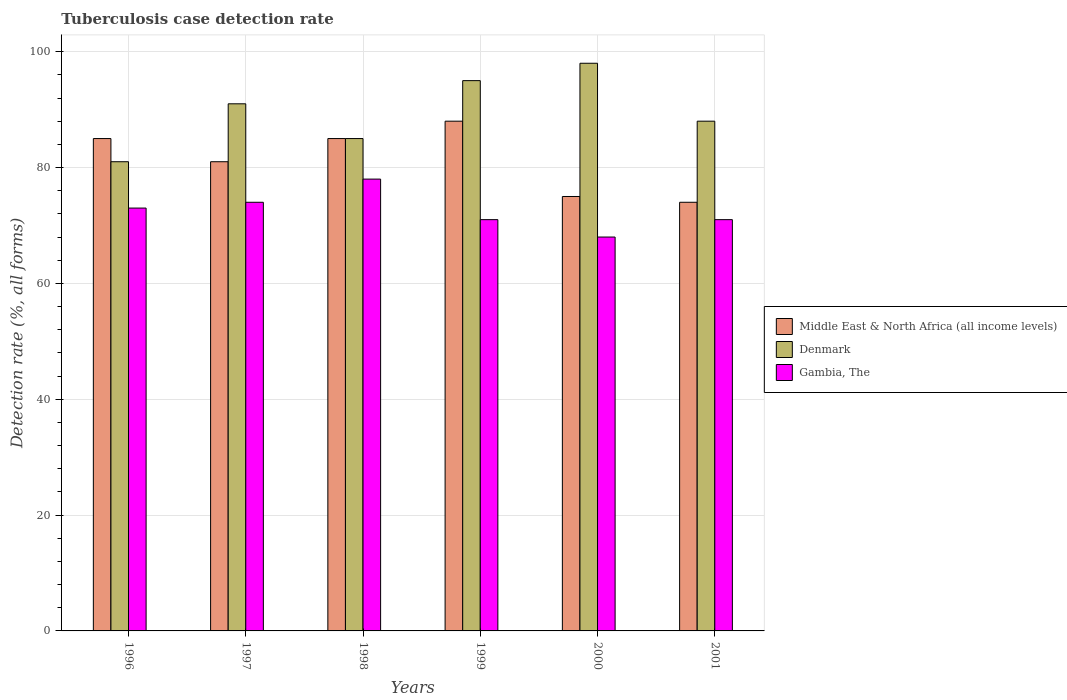In how many cases, is the number of bars for a given year not equal to the number of legend labels?
Provide a short and direct response. 0. Across all years, what is the maximum tuberculosis case detection rate in in Middle East & North Africa (all income levels)?
Give a very brief answer. 88. Across all years, what is the minimum tuberculosis case detection rate in in Gambia, The?
Your answer should be very brief. 68. In which year was the tuberculosis case detection rate in in Gambia, The maximum?
Ensure brevity in your answer.  1998. In which year was the tuberculosis case detection rate in in Middle East & North Africa (all income levels) minimum?
Your answer should be very brief. 2001. What is the total tuberculosis case detection rate in in Middle East & North Africa (all income levels) in the graph?
Provide a succinct answer. 488. What is the difference between the tuberculosis case detection rate in in Middle East & North Africa (all income levels) in 2000 and that in 2001?
Your answer should be very brief. 1. What is the difference between the tuberculosis case detection rate in in Middle East & North Africa (all income levels) in 1998 and the tuberculosis case detection rate in in Gambia, The in 2001?
Provide a succinct answer. 14. What is the average tuberculosis case detection rate in in Gambia, The per year?
Keep it short and to the point. 72.5. In the year 2001, what is the difference between the tuberculosis case detection rate in in Middle East & North Africa (all income levels) and tuberculosis case detection rate in in Gambia, The?
Offer a terse response. 3. What is the ratio of the tuberculosis case detection rate in in Denmark in 1997 to that in 1999?
Give a very brief answer. 0.96. What is the difference between the highest and the lowest tuberculosis case detection rate in in Denmark?
Your answer should be very brief. 17. In how many years, is the tuberculosis case detection rate in in Denmark greater than the average tuberculosis case detection rate in in Denmark taken over all years?
Your answer should be compact. 3. Is the sum of the tuberculosis case detection rate in in Middle East & North Africa (all income levels) in 1998 and 1999 greater than the maximum tuberculosis case detection rate in in Denmark across all years?
Your response must be concise. Yes. What does the 1st bar from the left in 1999 represents?
Provide a succinct answer. Middle East & North Africa (all income levels). What does the 2nd bar from the right in 2001 represents?
Offer a very short reply. Denmark. Is it the case that in every year, the sum of the tuberculosis case detection rate in in Gambia, The and tuberculosis case detection rate in in Middle East & North Africa (all income levels) is greater than the tuberculosis case detection rate in in Denmark?
Make the answer very short. Yes. Are all the bars in the graph horizontal?
Keep it short and to the point. No. How many years are there in the graph?
Your answer should be very brief. 6. Does the graph contain any zero values?
Give a very brief answer. No. Does the graph contain grids?
Keep it short and to the point. Yes. How are the legend labels stacked?
Provide a succinct answer. Vertical. What is the title of the graph?
Ensure brevity in your answer.  Tuberculosis case detection rate. What is the label or title of the X-axis?
Give a very brief answer. Years. What is the label or title of the Y-axis?
Ensure brevity in your answer.  Detection rate (%, all forms). What is the Detection rate (%, all forms) of Middle East & North Africa (all income levels) in 1996?
Keep it short and to the point. 85. What is the Detection rate (%, all forms) in Middle East & North Africa (all income levels) in 1997?
Your response must be concise. 81. What is the Detection rate (%, all forms) in Denmark in 1997?
Make the answer very short. 91. What is the Detection rate (%, all forms) in Middle East & North Africa (all income levels) in 1998?
Keep it short and to the point. 85. What is the Detection rate (%, all forms) in Gambia, The in 1998?
Your answer should be compact. 78. What is the Detection rate (%, all forms) in Denmark in 1999?
Offer a very short reply. 95. What is the Detection rate (%, all forms) in Middle East & North Africa (all income levels) in 2000?
Provide a succinct answer. 75. Across all years, what is the maximum Detection rate (%, all forms) in Middle East & North Africa (all income levels)?
Make the answer very short. 88. Across all years, what is the maximum Detection rate (%, all forms) of Denmark?
Give a very brief answer. 98. Across all years, what is the minimum Detection rate (%, all forms) in Middle East & North Africa (all income levels)?
Offer a terse response. 74. Across all years, what is the minimum Detection rate (%, all forms) in Gambia, The?
Offer a terse response. 68. What is the total Detection rate (%, all forms) of Middle East & North Africa (all income levels) in the graph?
Offer a terse response. 488. What is the total Detection rate (%, all forms) of Denmark in the graph?
Keep it short and to the point. 538. What is the total Detection rate (%, all forms) in Gambia, The in the graph?
Make the answer very short. 435. What is the difference between the Detection rate (%, all forms) in Denmark in 1996 and that in 1997?
Offer a terse response. -10. What is the difference between the Detection rate (%, all forms) of Gambia, The in 1996 and that in 1997?
Ensure brevity in your answer.  -1. What is the difference between the Detection rate (%, all forms) of Middle East & North Africa (all income levels) in 1996 and that in 1998?
Make the answer very short. 0. What is the difference between the Detection rate (%, all forms) in Middle East & North Africa (all income levels) in 1996 and that in 1999?
Keep it short and to the point. -3. What is the difference between the Detection rate (%, all forms) in Gambia, The in 1996 and that in 1999?
Make the answer very short. 2. What is the difference between the Detection rate (%, all forms) in Gambia, The in 1996 and that in 2000?
Give a very brief answer. 5. What is the difference between the Detection rate (%, all forms) of Denmark in 1996 and that in 2001?
Your answer should be compact. -7. What is the difference between the Detection rate (%, all forms) of Gambia, The in 1996 and that in 2001?
Make the answer very short. 2. What is the difference between the Detection rate (%, all forms) in Denmark in 1997 and that in 1998?
Give a very brief answer. 6. What is the difference between the Detection rate (%, all forms) of Gambia, The in 1997 and that in 1998?
Your response must be concise. -4. What is the difference between the Detection rate (%, all forms) in Middle East & North Africa (all income levels) in 1997 and that in 1999?
Offer a very short reply. -7. What is the difference between the Detection rate (%, all forms) in Gambia, The in 1997 and that in 1999?
Give a very brief answer. 3. What is the difference between the Detection rate (%, all forms) of Middle East & North Africa (all income levels) in 1997 and that in 2000?
Offer a terse response. 6. What is the difference between the Detection rate (%, all forms) of Middle East & North Africa (all income levels) in 1998 and that in 2000?
Provide a short and direct response. 10. What is the difference between the Detection rate (%, all forms) of Denmark in 1998 and that in 2000?
Offer a terse response. -13. What is the difference between the Detection rate (%, all forms) in Middle East & North Africa (all income levels) in 1998 and that in 2001?
Your answer should be compact. 11. What is the difference between the Detection rate (%, all forms) of Middle East & North Africa (all income levels) in 1999 and that in 2000?
Provide a succinct answer. 13. What is the difference between the Detection rate (%, all forms) in Denmark in 1999 and that in 2001?
Keep it short and to the point. 7. What is the difference between the Detection rate (%, all forms) in Gambia, The in 1999 and that in 2001?
Provide a succinct answer. 0. What is the difference between the Detection rate (%, all forms) of Middle East & North Africa (all income levels) in 2000 and that in 2001?
Offer a terse response. 1. What is the difference between the Detection rate (%, all forms) of Denmark in 2000 and that in 2001?
Your response must be concise. 10. What is the difference between the Detection rate (%, all forms) in Middle East & North Africa (all income levels) in 1996 and the Detection rate (%, all forms) in Gambia, The in 1997?
Give a very brief answer. 11. What is the difference between the Detection rate (%, all forms) in Denmark in 1996 and the Detection rate (%, all forms) in Gambia, The in 1997?
Your answer should be compact. 7. What is the difference between the Detection rate (%, all forms) of Denmark in 1996 and the Detection rate (%, all forms) of Gambia, The in 1998?
Provide a short and direct response. 3. What is the difference between the Detection rate (%, all forms) of Middle East & North Africa (all income levels) in 1996 and the Detection rate (%, all forms) of Denmark in 1999?
Offer a very short reply. -10. What is the difference between the Detection rate (%, all forms) in Middle East & North Africa (all income levels) in 1996 and the Detection rate (%, all forms) in Gambia, The in 1999?
Give a very brief answer. 14. What is the difference between the Detection rate (%, all forms) of Denmark in 1996 and the Detection rate (%, all forms) of Gambia, The in 2001?
Your response must be concise. 10. What is the difference between the Detection rate (%, all forms) in Middle East & North Africa (all income levels) in 1997 and the Detection rate (%, all forms) in Denmark in 1998?
Offer a terse response. -4. What is the difference between the Detection rate (%, all forms) in Middle East & North Africa (all income levels) in 1997 and the Detection rate (%, all forms) in Gambia, The in 1998?
Make the answer very short. 3. What is the difference between the Detection rate (%, all forms) in Denmark in 1997 and the Detection rate (%, all forms) in Gambia, The in 1998?
Offer a very short reply. 13. What is the difference between the Detection rate (%, all forms) of Middle East & North Africa (all income levels) in 1997 and the Detection rate (%, all forms) of Denmark in 1999?
Make the answer very short. -14. What is the difference between the Detection rate (%, all forms) in Middle East & North Africa (all income levels) in 1997 and the Detection rate (%, all forms) in Gambia, The in 1999?
Your answer should be very brief. 10. What is the difference between the Detection rate (%, all forms) of Denmark in 1997 and the Detection rate (%, all forms) of Gambia, The in 1999?
Provide a short and direct response. 20. What is the difference between the Detection rate (%, all forms) in Middle East & North Africa (all income levels) in 1997 and the Detection rate (%, all forms) in Gambia, The in 2000?
Ensure brevity in your answer.  13. What is the difference between the Detection rate (%, all forms) in Denmark in 1997 and the Detection rate (%, all forms) in Gambia, The in 2000?
Ensure brevity in your answer.  23. What is the difference between the Detection rate (%, all forms) of Middle East & North Africa (all income levels) in 1997 and the Detection rate (%, all forms) of Denmark in 2001?
Offer a terse response. -7. What is the difference between the Detection rate (%, all forms) in Middle East & North Africa (all income levels) in 1997 and the Detection rate (%, all forms) in Gambia, The in 2001?
Provide a short and direct response. 10. What is the difference between the Detection rate (%, all forms) of Denmark in 1998 and the Detection rate (%, all forms) of Gambia, The in 1999?
Ensure brevity in your answer.  14. What is the difference between the Detection rate (%, all forms) in Denmark in 1998 and the Detection rate (%, all forms) in Gambia, The in 2001?
Provide a short and direct response. 14. What is the difference between the Detection rate (%, all forms) of Middle East & North Africa (all income levels) in 1999 and the Detection rate (%, all forms) of Denmark in 2001?
Your response must be concise. 0. What is the difference between the Detection rate (%, all forms) of Middle East & North Africa (all income levels) in 1999 and the Detection rate (%, all forms) of Gambia, The in 2001?
Your answer should be compact. 17. What is the difference between the Detection rate (%, all forms) in Denmark in 1999 and the Detection rate (%, all forms) in Gambia, The in 2001?
Your response must be concise. 24. What is the difference between the Detection rate (%, all forms) of Middle East & North Africa (all income levels) in 2000 and the Detection rate (%, all forms) of Denmark in 2001?
Your answer should be very brief. -13. What is the difference between the Detection rate (%, all forms) of Middle East & North Africa (all income levels) in 2000 and the Detection rate (%, all forms) of Gambia, The in 2001?
Give a very brief answer. 4. What is the difference between the Detection rate (%, all forms) in Denmark in 2000 and the Detection rate (%, all forms) in Gambia, The in 2001?
Keep it short and to the point. 27. What is the average Detection rate (%, all forms) of Middle East & North Africa (all income levels) per year?
Provide a short and direct response. 81.33. What is the average Detection rate (%, all forms) in Denmark per year?
Make the answer very short. 89.67. What is the average Detection rate (%, all forms) in Gambia, The per year?
Keep it short and to the point. 72.5. In the year 1996, what is the difference between the Detection rate (%, all forms) in Middle East & North Africa (all income levels) and Detection rate (%, all forms) in Denmark?
Offer a terse response. 4. In the year 1999, what is the difference between the Detection rate (%, all forms) in Middle East & North Africa (all income levels) and Detection rate (%, all forms) in Gambia, The?
Ensure brevity in your answer.  17. In the year 2000, what is the difference between the Detection rate (%, all forms) in Denmark and Detection rate (%, all forms) in Gambia, The?
Provide a succinct answer. 30. In the year 2001, what is the difference between the Detection rate (%, all forms) in Middle East & North Africa (all income levels) and Detection rate (%, all forms) in Gambia, The?
Offer a terse response. 3. What is the ratio of the Detection rate (%, all forms) of Middle East & North Africa (all income levels) in 1996 to that in 1997?
Your answer should be very brief. 1.05. What is the ratio of the Detection rate (%, all forms) of Denmark in 1996 to that in 1997?
Offer a very short reply. 0.89. What is the ratio of the Detection rate (%, all forms) in Gambia, The in 1996 to that in 1997?
Your answer should be compact. 0.99. What is the ratio of the Detection rate (%, all forms) of Denmark in 1996 to that in 1998?
Ensure brevity in your answer.  0.95. What is the ratio of the Detection rate (%, all forms) in Gambia, The in 1996 to that in 1998?
Your answer should be compact. 0.94. What is the ratio of the Detection rate (%, all forms) of Middle East & North Africa (all income levels) in 1996 to that in 1999?
Your answer should be compact. 0.97. What is the ratio of the Detection rate (%, all forms) of Denmark in 1996 to that in 1999?
Provide a succinct answer. 0.85. What is the ratio of the Detection rate (%, all forms) in Gambia, The in 1996 to that in 1999?
Provide a succinct answer. 1.03. What is the ratio of the Detection rate (%, all forms) of Middle East & North Africa (all income levels) in 1996 to that in 2000?
Make the answer very short. 1.13. What is the ratio of the Detection rate (%, all forms) in Denmark in 1996 to that in 2000?
Provide a short and direct response. 0.83. What is the ratio of the Detection rate (%, all forms) of Gambia, The in 1996 to that in 2000?
Give a very brief answer. 1.07. What is the ratio of the Detection rate (%, all forms) of Middle East & North Africa (all income levels) in 1996 to that in 2001?
Your answer should be very brief. 1.15. What is the ratio of the Detection rate (%, all forms) in Denmark in 1996 to that in 2001?
Provide a short and direct response. 0.92. What is the ratio of the Detection rate (%, all forms) in Gambia, The in 1996 to that in 2001?
Make the answer very short. 1.03. What is the ratio of the Detection rate (%, all forms) in Middle East & North Africa (all income levels) in 1997 to that in 1998?
Your answer should be compact. 0.95. What is the ratio of the Detection rate (%, all forms) in Denmark in 1997 to that in 1998?
Keep it short and to the point. 1.07. What is the ratio of the Detection rate (%, all forms) of Gambia, The in 1997 to that in 1998?
Offer a very short reply. 0.95. What is the ratio of the Detection rate (%, all forms) in Middle East & North Africa (all income levels) in 1997 to that in 1999?
Offer a very short reply. 0.92. What is the ratio of the Detection rate (%, all forms) in Denmark in 1997 to that in 1999?
Make the answer very short. 0.96. What is the ratio of the Detection rate (%, all forms) in Gambia, The in 1997 to that in 1999?
Ensure brevity in your answer.  1.04. What is the ratio of the Detection rate (%, all forms) of Middle East & North Africa (all income levels) in 1997 to that in 2000?
Your answer should be compact. 1.08. What is the ratio of the Detection rate (%, all forms) of Gambia, The in 1997 to that in 2000?
Make the answer very short. 1.09. What is the ratio of the Detection rate (%, all forms) of Middle East & North Africa (all income levels) in 1997 to that in 2001?
Your answer should be very brief. 1.09. What is the ratio of the Detection rate (%, all forms) in Denmark in 1997 to that in 2001?
Offer a terse response. 1.03. What is the ratio of the Detection rate (%, all forms) of Gambia, The in 1997 to that in 2001?
Keep it short and to the point. 1.04. What is the ratio of the Detection rate (%, all forms) of Middle East & North Africa (all income levels) in 1998 to that in 1999?
Your answer should be very brief. 0.97. What is the ratio of the Detection rate (%, all forms) in Denmark in 1998 to that in 1999?
Your response must be concise. 0.89. What is the ratio of the Detection rate (%, all forms) in Gambia, The in 1998 to that in 1999?
Offer a very short reply. 1.1. What is the ratio of the Detection rate (%, all forms) in Middle East & North Africa (all income levels) in 1998 to that in 2000?
Make the answer very short. 1.13. What is the ratio of the Detection rate (%, all forms) of Denmark in 1998 to that in 2000?
Keep it short and to the point. 0.87. What is the ratio of the Detection rate (%, all forms) in Gambia, The in 1998 to that in 2000?
Offer a very short reply. 1.15. What is the ratio of the Detection rate (%, all forms) of Middle East & North Africa (all income levels) in 1998 to that in 2001?
Keep it short and to the point. 1.15. What is the ratio of the Detection rate (%, all forms) in Denmark in 1998 to that in 2001?
Provide a short and direct response. 0.97. What is the ratio of the Detection rate (%, all forms) of Gambia, The in 1998 to that in 2001?
Provide a short and direct response. 1.1. What is the ratio of the Detection rate (%, all forms) of Middle East & North Africa (all income levels) in 1999 to that in 2000?
Offer a very short reply. 1.17. What is the ratio of the Detection rate (%, all forms) in Denmark in 1999 to that in 2000?
Provide a short and direct response. 0.97. What is the ratio of the Detection rate (%, all forms) of Gambia, The in 1999 to that in 2000?
Give a very brief answer. 1.04. What is the ratio of the Detection rate (%, all forms) in Middle East & North Africa (all income levels) in 1999 to that in 2001?
Offer a terse response. 1.19. What is the ratio of the Detection rate (%, all forms) in Denmark in 1999 to that in 2001?
Keep it short and to the point. 1.08. What is the ratio of the Detection rate (%, all forms) of Gambia, The in 1999 to that in 2001?
Make the answer very short. 1. What is the ratio of the Detection rate (%, all forms) in Middle East & North Africa (all income levels) in 2000 to that in 2001?
Make the answer very short. 1.01. What is the ratio of the Detection rate (%, all forms) of Denmark in 2000 to that in 2001?
Your answer should be very brief. 1.11. What is the ratio of the Detection rate (%, all forms) in Gambia, The in 2000 to that in 2001?
Offer a very short reply. 0.96. What is the difference between the highest and the second highest Detection rate (%, all forms) in Middle East & North Africa (all income levels)?
Provide a short and direct response. 3. What is the difference between the highest and the second highest Detection rate (%, all forms) of Denmark?
Keep it short and to the point. 3. What is the difference between the highest and the lowest Detection rate (%, all forms) in Denmark?
Your response must be concise. 17. What is the difference between the highest and the lowest Detection rate (%, all forms) in Gambia, The?
Make the answer very short. 10. 